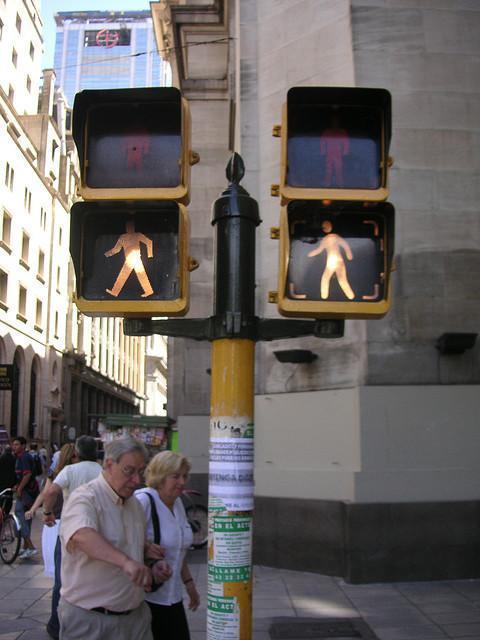How many people are there?
Give a very brief answer. 3. How many traffic lights are there?
Give a very brief answer. 2. 